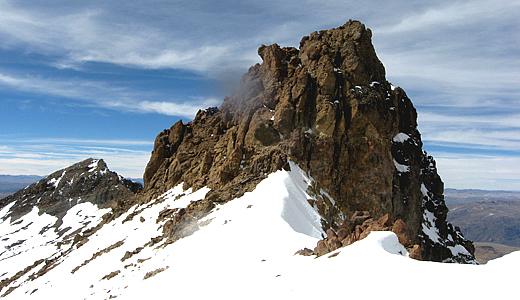Describe the following image. The image showcases the stunning Nevado Mismi, a recognized peak within the Andes mountain range in Peru. The perspective of the photograph offers a majestic view of the peak, which distinctly rises against the clear sky. The summit is adorned with a blanket of snow, lending it an immaculate and ethereal quality. To the side of the peak, a stark, rocky outcrop provides a rugged contrast to the smooth, snow-covered slopes. The sky is mostly blue with a smattering of clouds, further accentuating the natural splendor of the scene. The photograph conveys a serene and awe-inspiring ambiance, typical of expansive natural landscapes. Below the peak, the Andes' undulating terrain unfolds, adding depth to the picture with distant, contrasting brown and green hues of the mountains. 